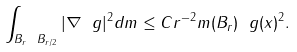Convert formula to latex. <formula><loc_0><loc_0><loc_500><loc_500>\int _ { B _ { r } \ B _ { r / 2 } } | \nabla \ g | ^ { 2 } d m \leq C r ^ { - 2 } m ( B _ { r } ) \ g ( x ) ^ { 2 } .</formula> 